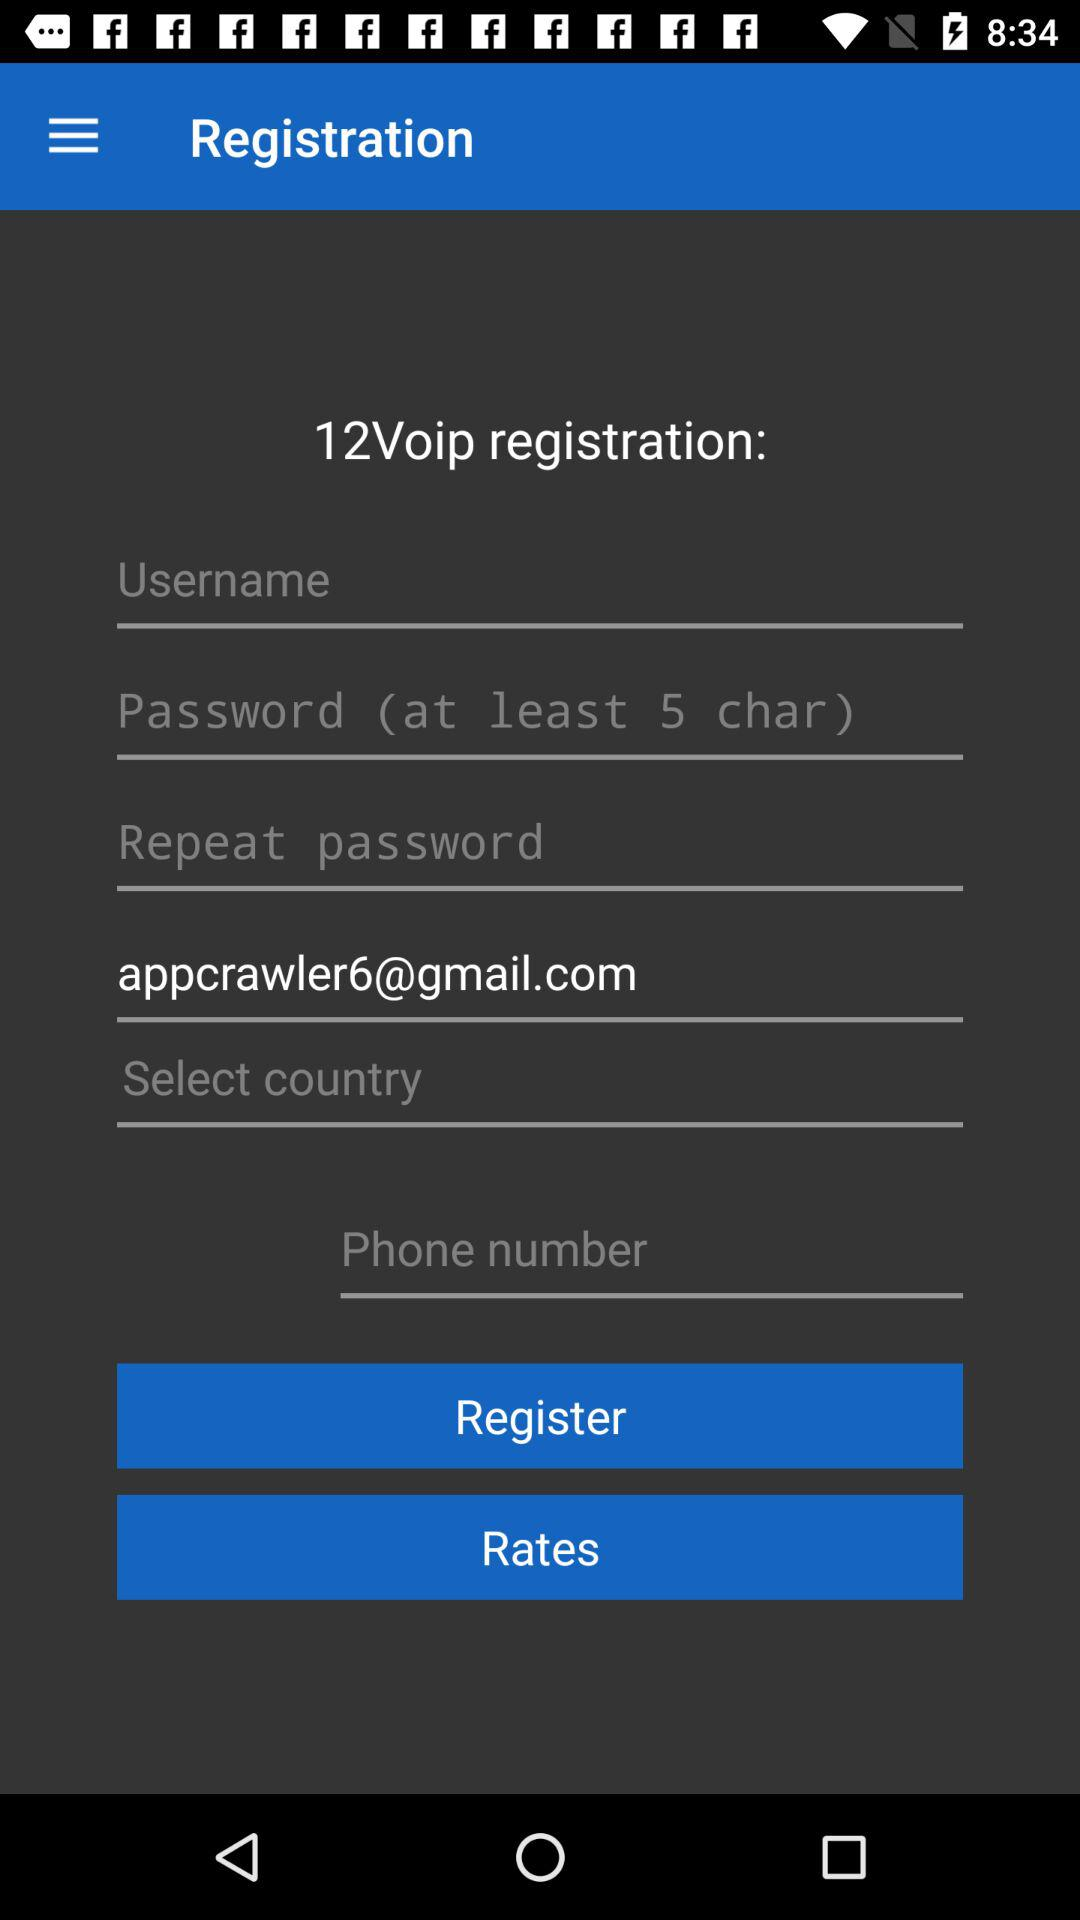What is the email address? The email address is "appcrawler6@gmail.com". 